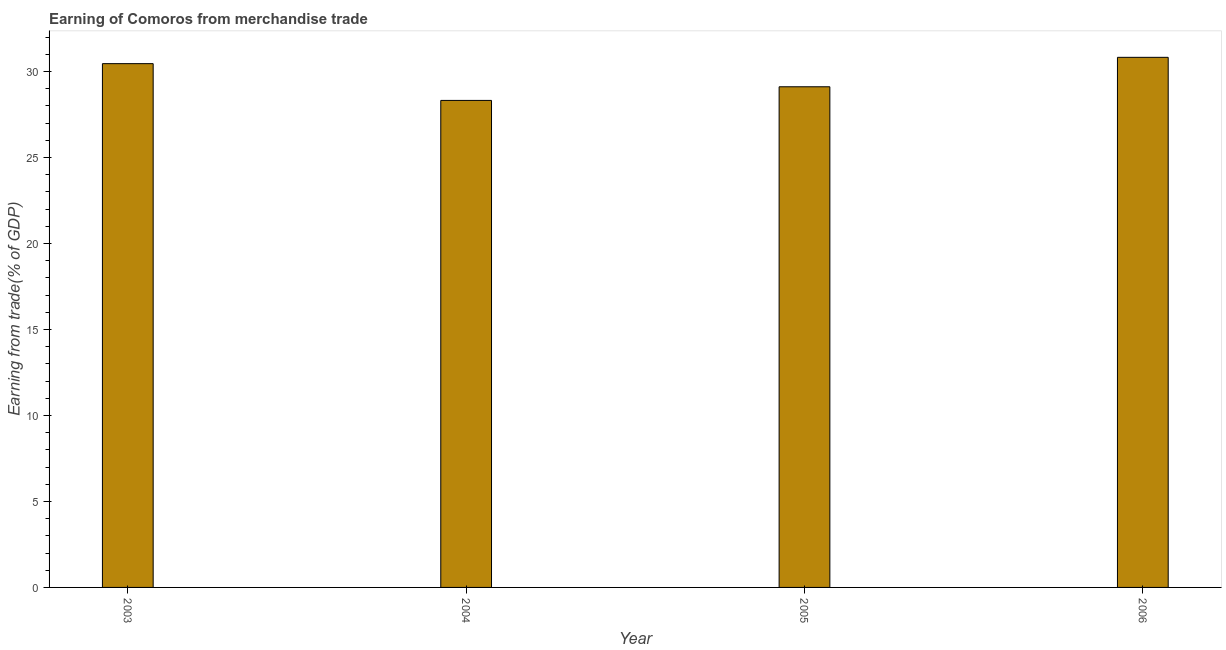Does the graph contain grids?
Your answer should be compact. No. What is the title of the graph?
Your answer should be compact. Earning of Comoros from merchandise trade. What is the label or title of the Y-axis?
Give a very brief answer. Earning from trade(% of GDP). What is the earning from merchandise trade in 2004?
Your answer should be compact. 28.31. Across all years, what is the maximum earning from merchandise trade?
Ensure brevity in your answer.  30.82. Across all years, what is the minimum earning from merchandise trade?
Offer a terse response. 28.31. In which year was the earning from merchandise trade maximum?
Keep it short and to the point. 2006. What is the sum of the earning from merchandise trade?
Your answer should be very brief. 118.69. What is the difference between the earning from merchandise trade in 2004 and 2006?
Ensure brevity in your answer.  -2.5. What is the average earning from merchandise trade per year?
Offer a very short reply. 29.67. What is the median earning from merchandise trade?
Keep it short and to the point. 29.78. What is the ratio of the earning from merchandise trade in 2003 to that in 2005?
Offer a terse response. 1.05. Is the earning from merchandise trade in 2004 less than that in 2006?
Provide a succinct answer. Yes. What is the difference between the highest and the second highest earning from merchandise trade?
Keep it short and to the point. 0.37. Is the sum of the earning from merchandise trade in 2004 and 2005 greater than the maximum earning from merchandise trade across all years?
Make the answer very short. Yes. What is the difference between the highest and the lowest earning from merchandise trade?
Give a very brief answer. 2.5. In how many years, is the earning from merchandise trade greater than the average earning from merchandise trade taken over all years?
Make the answer very short. 2. What is the difference between two consecutive major ticks on the Y-axis?
Your answer should be very brief. 5. Are the values on the major ticks of Y-axis written in scientific E-notation?
Ensure brevity in your answer.  No. What is the Earning from trade(% of GDP) in 2003?
Give a very brief answer. 30.45. What is the Earning from trade(% of GDP) in 2004?
Ensure brevity in your answer.  28.31. What is the Earning from trade(% of GDP) in 2005?
Ensure brevity in your answer.  29.11. What is the Earning from trade(% of GDP) of 2006?
Your answer should be compact. 30.82. What is the difference between the Earning from trade(% of GDP) in 2003 and 2004?
Your answer should be very brief. 2.14. What is the difference between the Earning from trade(% of GDP) in 2003 and 2005?
Offer a very short reply. 1.34. What is the difference between the Earning from trade(% of GDP) in 2003 and 2006?
Give a very brief answer. -0.37. What is the difference between the Earning from trade(% of GDP) in 2004 and 2005?
Your response must be concise. -0.79. What is the difference between the Earning from trade(% of GDP) in 2004 and 2006?
Your answer should be compact. -2.5. What is the difference between the Earning from trade(% of GDP) in 2005 and 2006?
Keep it short and to the point. -1.71. What is the ratio of the Earning from trade(% of GDP) in 2003 to that in 2004?
Your answer should be very brief. 1.07. What is the ratio of the Earning from trade(% of GDP) in 2003 to that in 2005?
Make the answer very short. 1.05. What is the ratio of the Earning from trade(% of GDP) in 2003 to that in 2006?
Your response must be concise. 0.99. What is the ratio of the Earning from trade(% of GDP) in 2004 to that in 2005?
Your answer should be compact. 0.97. What is the ratio of the Earning from trade(% of GDP) in 2004 to that in 2006?
Your response must be concise. 0.92. What is the ratio of the Earning from trade(% of GDP) in 2005 to that in 2006?
Your response must be concise. 0.94. 